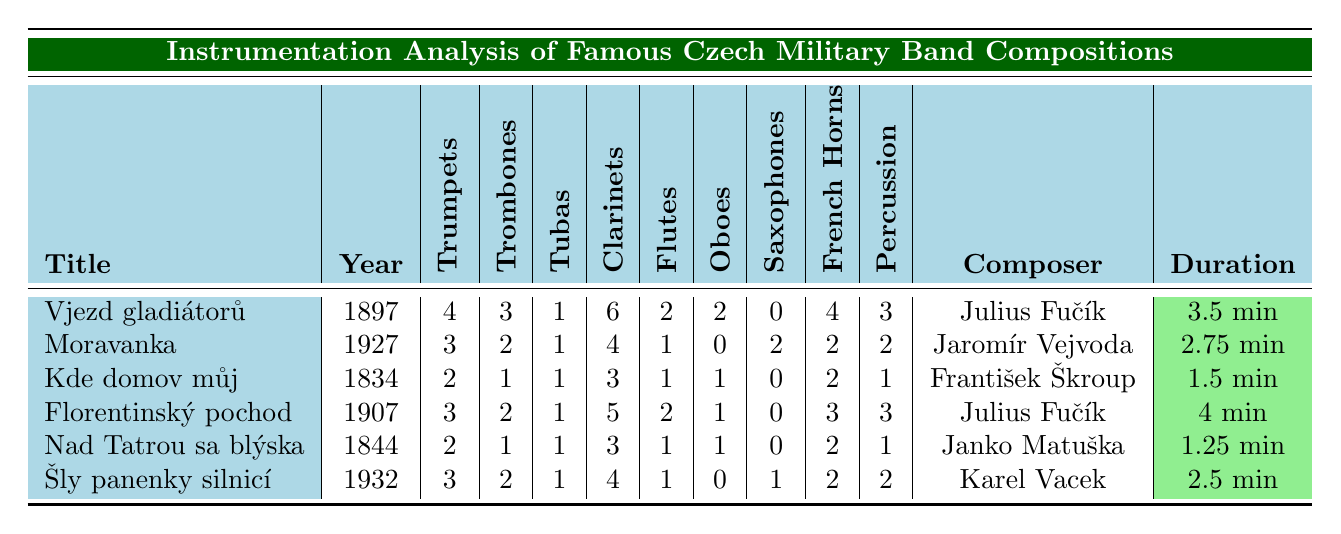What is the title of the composition with the most trumpets? Looking at the "Trumpets" column, the highest value is 4, which corresponds to the composition "Vjezd gladiátorů".
Answer: Vjezd gladiátorů Who composed "Moravanka"? The composer listed for "Moravanka" in the table is Jaromír Vejvoda.
Answer: Jaromír Vejvoda How many clarinets are used in "Florentinský pochod"? The "Clarinets" column shows a value of 5 for "Florentinský pochod".
Answer: 5 What is the average duration of all the compositions? Summing up the durations: 3.5 + 2.75 + 1.5 + 4 + 1.25 + 2.5 = 15.5 minutes. There are 6 compositions, so the average is 15.5 / 6 ≈ 2.58 minutes.
Answer: Approximately 2.58 minutes Does "Kde domov můj" have any saxophones? In the "Saxophones" column for "Kde domov můj", the value is 0, which means it does not have any saxophones.
Answer: No Which composition has the least number of percussion instruments? The "Percussion" column shows the least value of 1 for both "Kde domov můj" and "Nad Tatrou sa blýska", but "Nad Tatrou sa blýska" is the earliest composition.
Answer: Nad Tatrou sa blýska What is the total number of tubas across all compositions? Adding the tubas from each composition: 1 + 1 + 1 + 1 + 1 + 1 = 6.
Answer: 6 Which composer has the largest number of compositions listed in the table? Julius Fučík composed two compositions: "Vjezd gladiátorů" and "Florentinský pochod". The other composers each have one composition.
Answer: Julius Fučík How do the total number of flutes compare to the total number of trumpets in all compositions? Total flutes: 2 + 1 + 1 + 2 + 1 + 1 = 8. Total trumpets: 4 + 3 + 2 + 3 + 2 + 3 = 17. Since 8 is less than 17, flutes are fewer than trumpets.
Answer: Fewer Is there any composition that includes more than 4 French horns? Reviewing the "French Horns" column, the maximum is 4 for "Vjezd gladiátorů". Therefore, no composition has more than 4 French horns.
Answer: No 